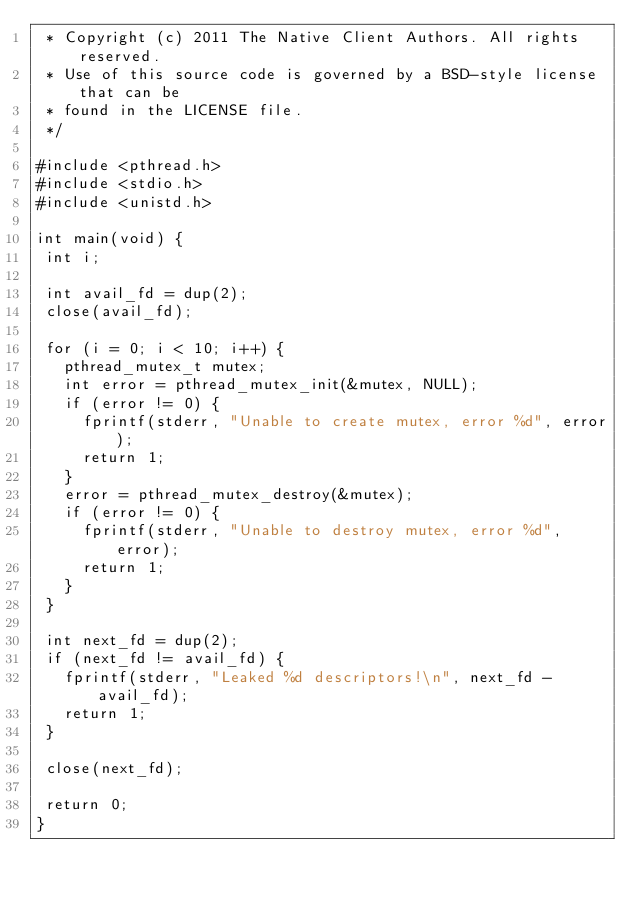<code> <loc_0><loc_0><loc_500><loc_500><_C_> * Copyright (c) 2011 The Native Client Authors. All rights reserved.
 * Use of this source code is governed by a BSD-style license that can be
 * found in the LICENSE file.
 */

#include <pthread.h>
#include <stdio.h>
#include <unistd.h>

int main(void) {
 int i;

 int avail_fd = dup(2);
 close(avail_fd);

 for (i = 0; i < 10; i++) {
   pthread_mutex_t mutex;
   int error = pthread_mutex_init(&mutex, NULL);
   if (error != 0) {
     fprintf(stderr, "Unable to create mutex, error %d", error);
     return 1;
   }
   error = pthread_mutex_destroy(&mutex);
   if (error != 0) {
     fprintf(stderr, "Unable to destroy mutex, error %d", error);
     return 1;
   }
 }

 int next_fd = dup(2);
 if (next_fd != avail_fd) {
   fprintf(stderr, "Leaked %d descriptors!\n", next_fd - avail_fd);
   return 1;
 }

 close(next_fd);

 return 0;
}
</code> 